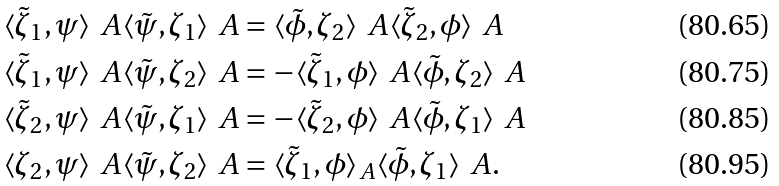Convert formula to latex. <formula><loc_0><loc_0><loc_500><loc_500>\langle \tilde { \zeta } _ { 1 } , \psi \rangle _ { \ } A \langle \tilde { \psi } , \zeta _ { 1 } \rangle _ { \ } A & = \langle \tilde { \phi } , \zeta _ { 2 } \rangle _ { \ } A \langle \tilde { \zeta } _ { 2 } , \phi \rangle _ { \ } A \\ \langle \tilde { \zeta } _ { 1 } , \psi \rangle _ { \ } A \langle \tilde { \psi } , \zeta _ { 2 } \rangle _ { \ } A & = - \langle \tilde { \zeta } _ { 1 } , \phi \rangle _ { \ } A \langle \tilde { \phi } , \zeta _ { 2 } \rangle _ { \ } A \\ \langle \tilde { \zeta } _ { 2 } , \psi \rangle _ { \ } A \langle \tilde { \psi } , \zeta _ { 1 } \rangle _ { \ } A & = - \langle \tilde { \zeta } _ { 2 } , \phi \rangle _ { \ } A \langle \tilde { \phi } , \zeta _ { 1 } \rangle _ { \ } A \\ \langle \zeta _ { 2 } , \psi \rangle _ { \ } A \langle \tilde { \psi } , \zeta _ { 2 } \rangle _ { \ } A & = \langle \tilde { \zeta } _ { 1 } , \phi \rangle _ { A } \langle \tilde { \phi } , \zeta _ { 1 } \rangle _ { \ } A .</formula> 